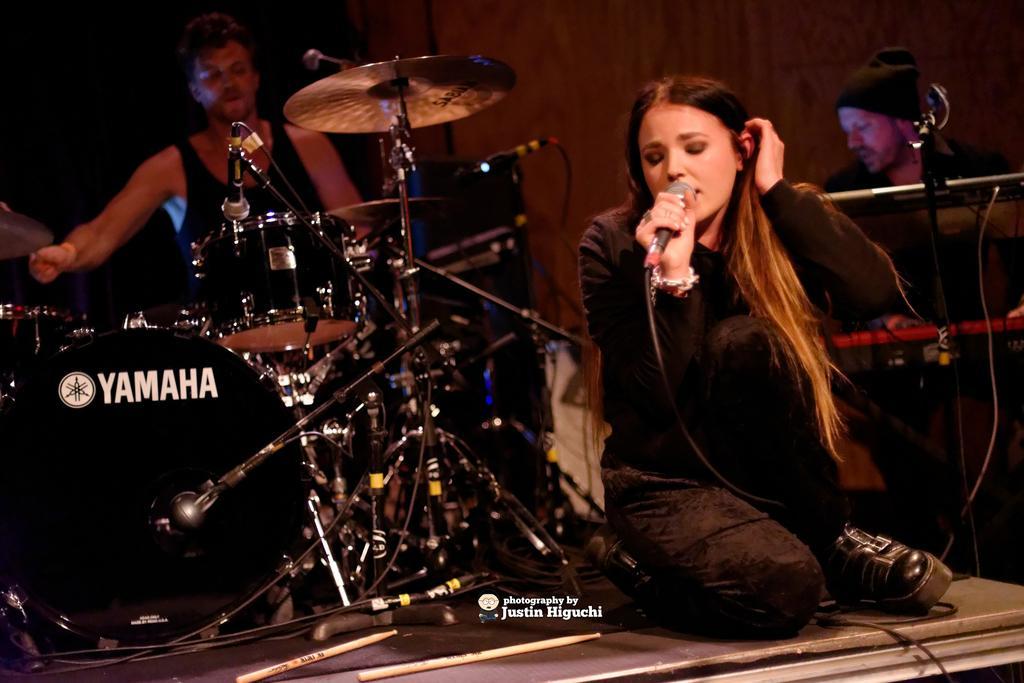Could you give a brief overview of what you see in this image? A girl who is in black shirt and jeans holding a mike is sitting on the floor and beside her there are some musical instruments on which it is written as yamaha. 